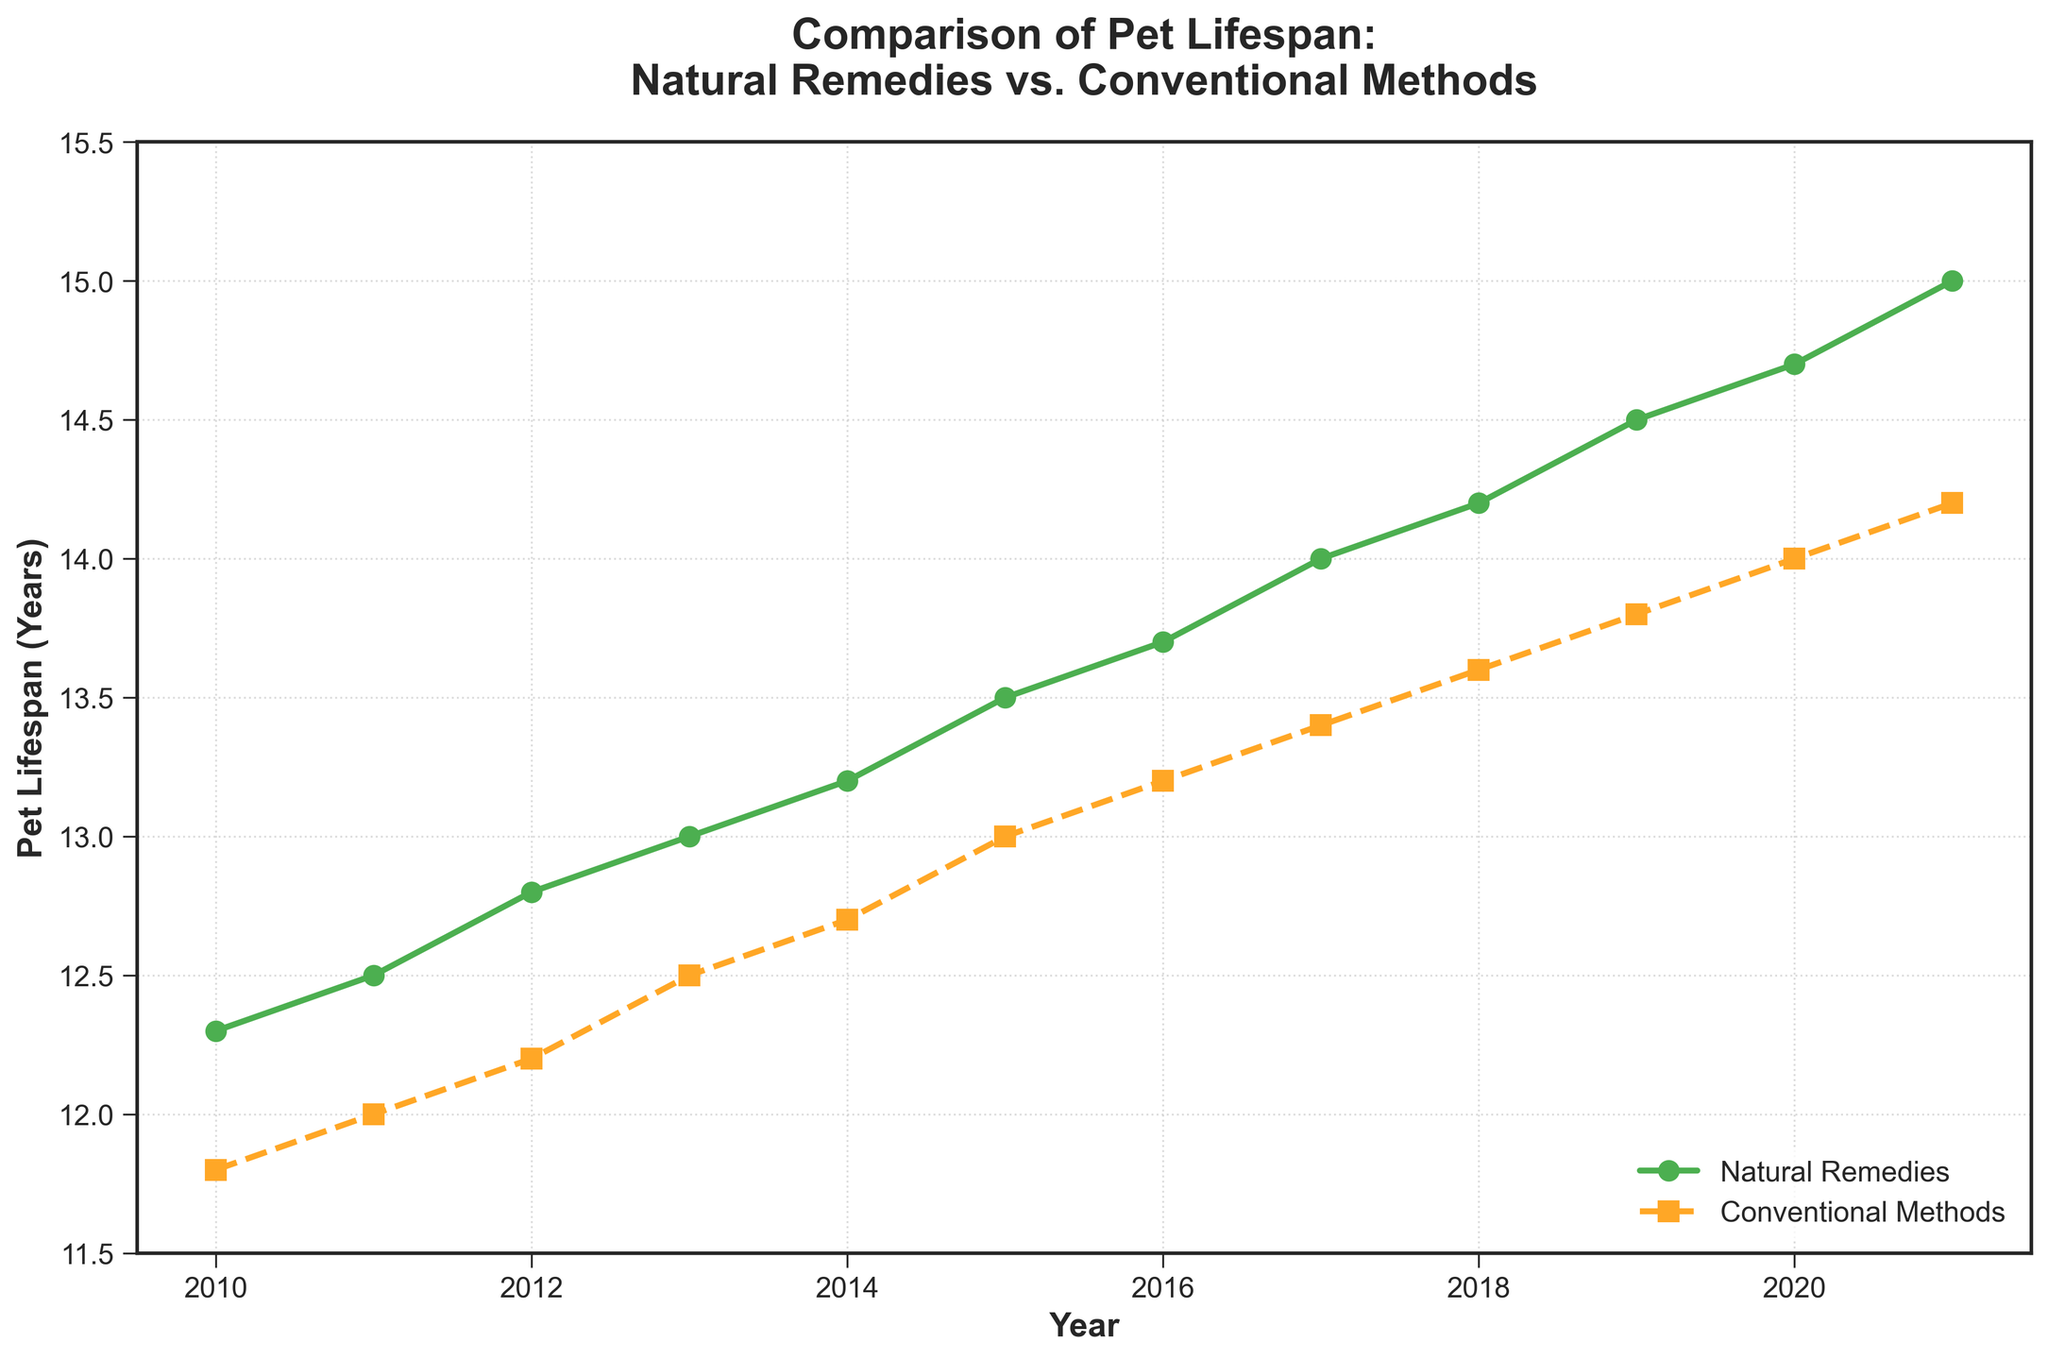What's the year where the lifespan difference between natural remedies and conventional methods is the largest? To find this, look at the vertical distance between the two lines for each year. The largest difference occurs in the year 2021. The natural remedies lifespan is 15.0 years, and the conventional method lifespan is 14.2 years, giving a difference of 0.8 years.
Answer: 2021 In which year do pets treated with conventional methods reach a lifespan of 14 years? Examine the lifespan values for conventional methods. The lifespan reaches 14 years in 2020.
Answer: 2020 What's the average lifespan of pets treated with natural remedies between 2010 and 2021? Add all the available lifespan values for natural remedies from 2010 to 2021 and then divide by the number of years (12). The average is (12.3 + 12.5 + 12.8 + 13.0 + 13.2 + 13.5 + 13.7 + 14.0 + 14.2 + 14.5 + 14.7 + 15.0) / 12 = 13.75 years.
Answer: 13.75 How many years does it take for pets treated with conventional methods to reach a lifespan of 13 years from 2010? Find the year when the lifespan for conventional methods reaches 13 years, which is 2015. The time taken is from 2010 to 2015, which is 2015 - 2010 = 5 years.
Answer: 5 years In which year do both lines cross representing close lifespan values, and what is the difference? Examine the years where the lines representing natural remedies and conventional methods are closest. They cross around the year 2020 with a natural lifespan of 14.7 years and conventional lifespan of 14.0 years, the difference being 0.7 years.
Answer: 2020, 0.7 years What is the overall trend in pet lifespans for both treatments from 2010 to 2021? Look at both lines' directions from start to end. The lifespan values for both natural remedies and conventional methods show an increasing trend from 2010 to 2021.
Answer: Increasing Between which consecutive years is the largest increase in lifespan for pets treated with natural remedies observed? Compare the yearly increases in lifespan values for natural remedies. The largest increase occurs between 2011 and 2012, where the value increases from 12.5 to 12.8, a difference of 0.3 years.
Answer: 2011-2012 Comparing 2010 and 2021, by how much did the lifespan increase for pets treated with natural remedies and conventional methods? For natural remedies, the increase is 15.0 (2021) - 12.3 (2010) = 2.7 years. For conventional methods, the increase is 14.2 (2021) - 11.8 (2010) = 2.4 years.
Answer: 2.7, 2.4 years Which treatment method shows a consistent increase in pet lifespan every year from 2010 to 2021? Check if every subsequent year has a higher lifespan value than the previous year for each method. Both natural remedies and conventional methods show consistent yearly increases.
Answer: Both 